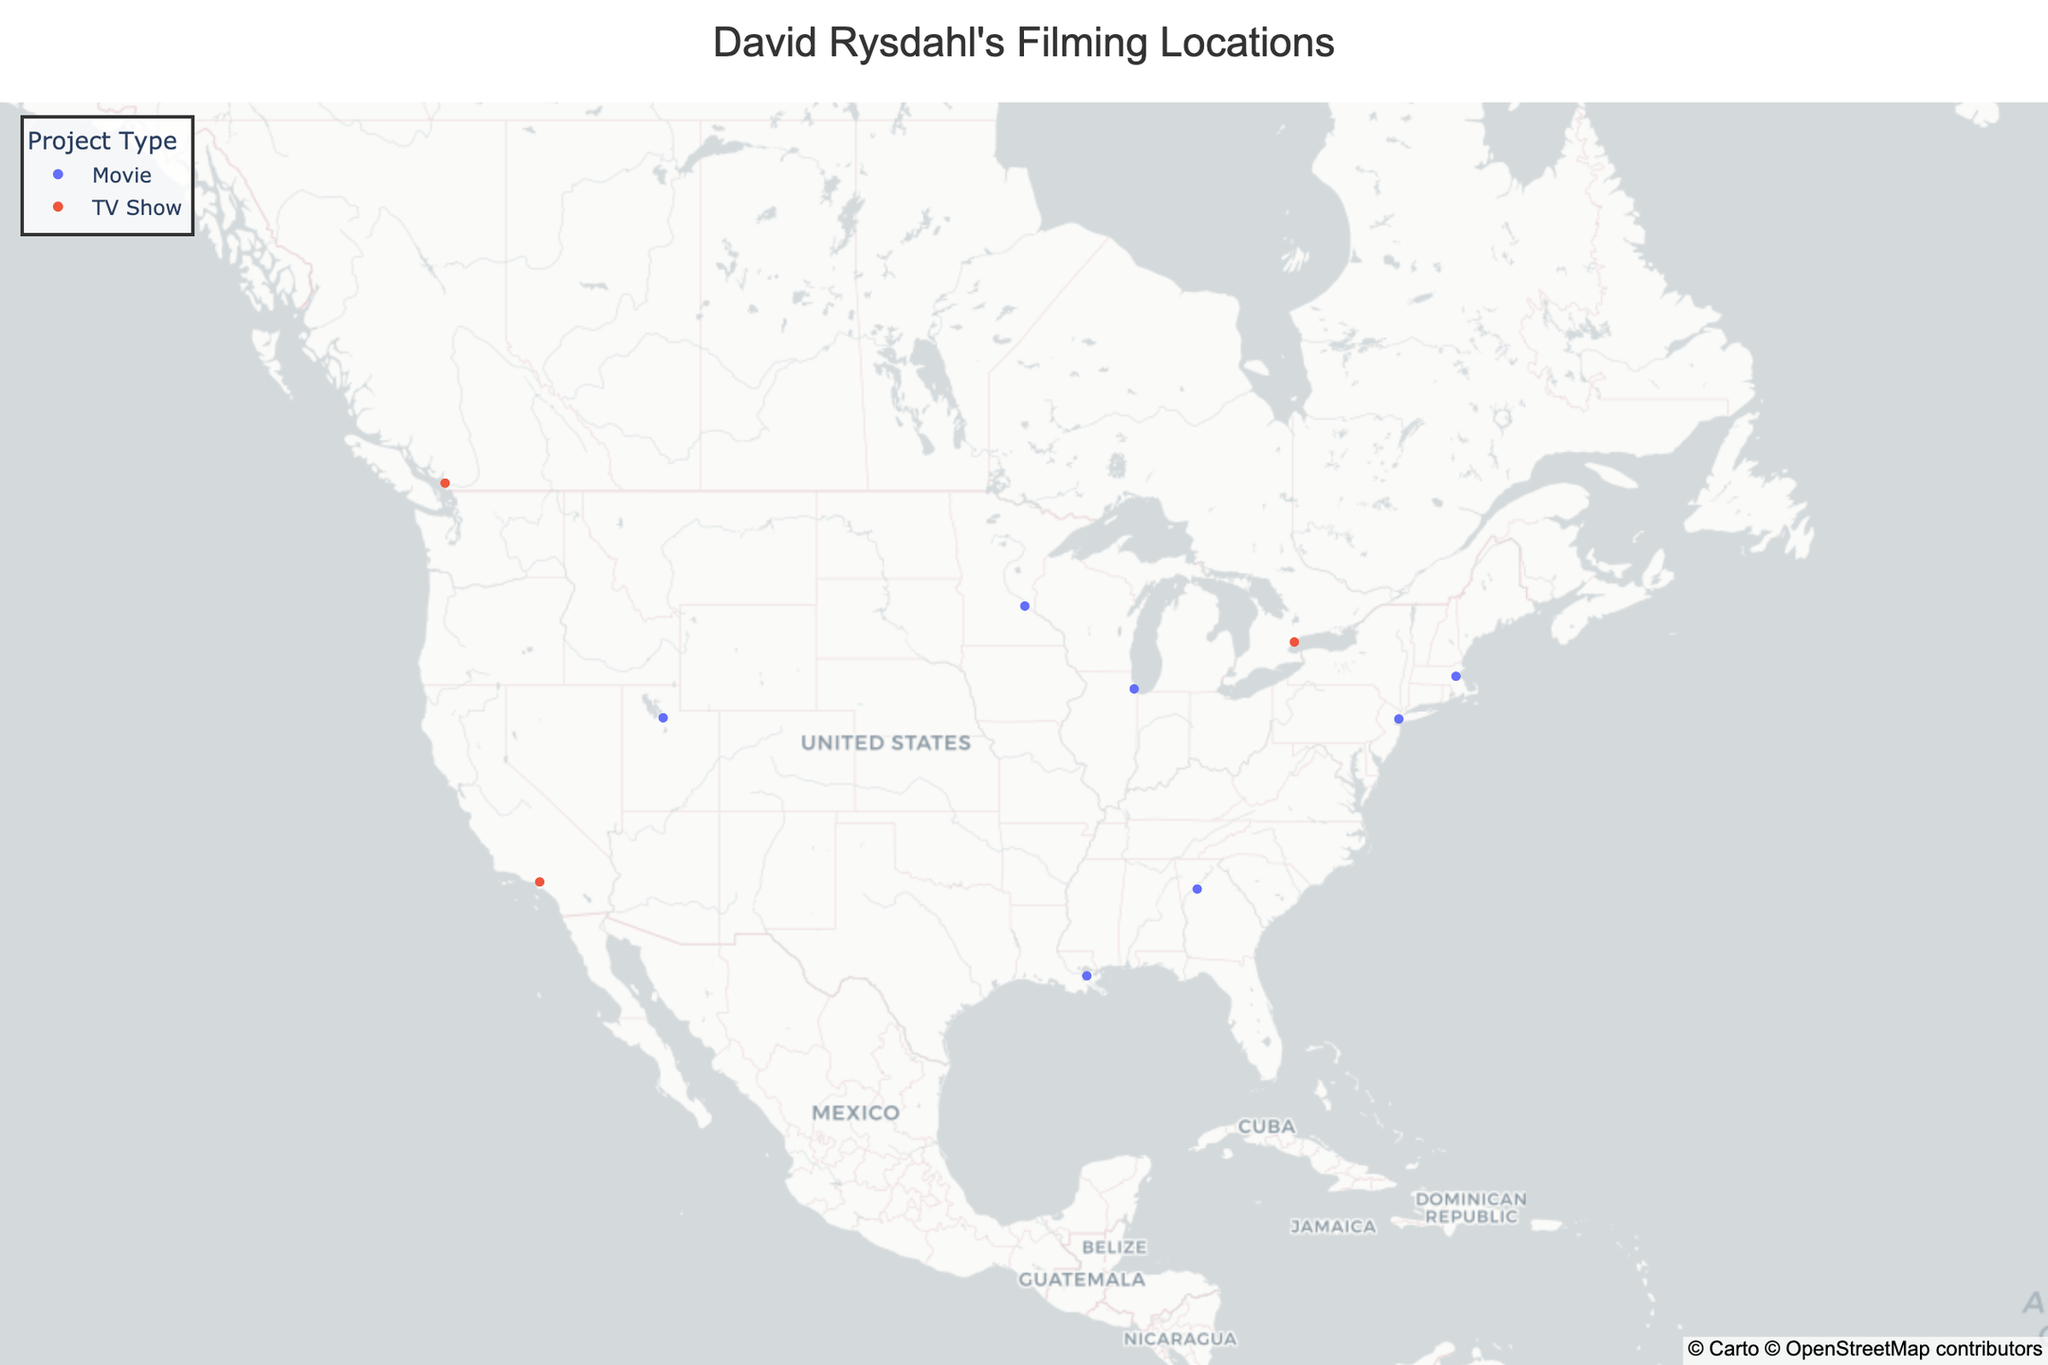What is the title of the map? The title is the text prominently displayed at the top of the map.
Answer: David Rysdahl's Filming Locations How many TV shows featuring David Rysdahl have filming locations shown on the map? By looking at the legend and the points color-coded as TV shows, we can count the number of TV show data points. There are 4 TV show points.
Answer: 4 What is the filming location with the most recent production date? By examining the hover information, the point representing "Oppenheimer" in Minneapolis is the most recent with a production date of July 2023.
Answer: Minneapolis What are the two projects filmed in 2020? By looking at the hover data for all points, we see that "Fargo" in Vancouver and "Nine Days" in Salt Lake City were filmed in 2020.
Answer: Fargo and Nine Days Which filming location is the furthest north? The point with the highest latitude value is the furthest north. "Fargo" in Vancouver has the highest latitude at 49.2827.
Answer: Vancouver Which project types have more locations on the map, movies or TV shows? Counting the number of points categorized as movies and as TV shows, movies have more locations.
Answer: Movies Are any projects of the same type filmed in the same city? Checking each city's hover data, no projects of the same type are filmed in the same city.
Answer: No How many filming locations are there on the East Coast of the USA? Examining the points plotted geographically on the East Coast, New York City and Boston are the locations. There are 2 locations.
Answer: 2 What is the southernmost filming location? The point with the lowest latitude is the southernmost. "The Menu" in New Orleans is the southernmost with a latitude of 29.9511.
Answer: New Orleans In which month did the most filming activities occur? By examining the production dates in the hover data, November 2022 has the highest number with two projects: "Bones and All" and "The Menu".
Answer: November 